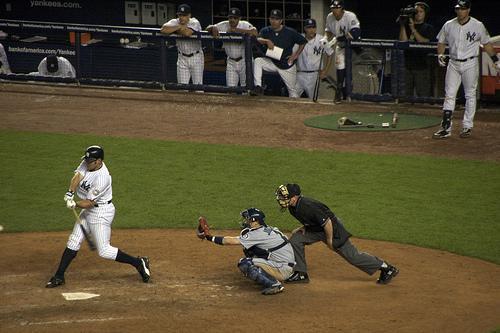Why does the kneeling man crouch low?
Select the correct answer and articulate reasoning with the following format: 'Answer: answer
Rationale: rationale.'
Options: Catch ball, he's tired, wave hello, clean base. Answer: catch ball.
Rationale: This is because the ball drops as it crosses the plate 